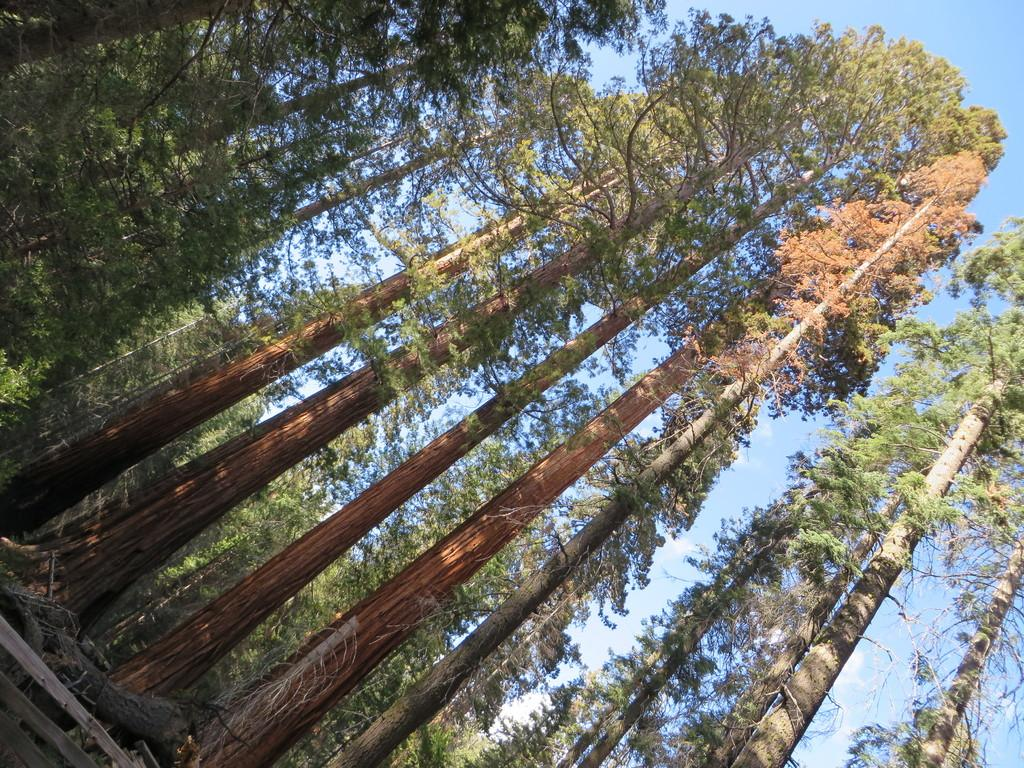What objects are on the ground in the image? There are logs and twigs on the ground in the image. What type of vegetation is visible in the image? There are trees visible in the image. What is visible in the background of the image? The sky is visible in the background of the image. What can be seen in the sky in the background of the image? Clouds are present in the sky in the background of the image. How many feet are visible in the image? There are no feet visible in the image. What type of animals can be seen at the zoo in the image? There is no zoo present in the image, so it is not possible to determine what animals might be seen there. 